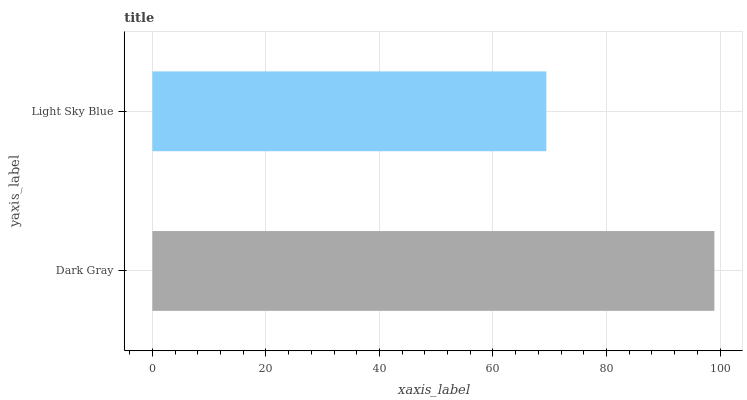Is Light Sky Blue the minimum?
Answer yes or no. Yes. Is Dark Gray the maximum?
Answer yes or no. Yes. Is Light Sky Blue the maximum?
Answer yes or no. No. Is Dark Gray greater than Light Sky Blue?
Answer yes or no. Yes. Is Light Sky Blue less than Dark Gray?
Answer yes or no. Yes. Is Light Sky Blue greater than Dark Gray?
Answer yes or no. No. Is Dark Gray less than Light Sky Blue?
Answer yes or no. No. Is Dark Gray the high median?
Answer yes or no. Yes. Is Light Sky Blue the low median?
Answer yes or no. Yes. Is Light Sky Blue the high median?
Answer yes or no. No. Is Dark Gray the low median?
Answer yes or no. No. 